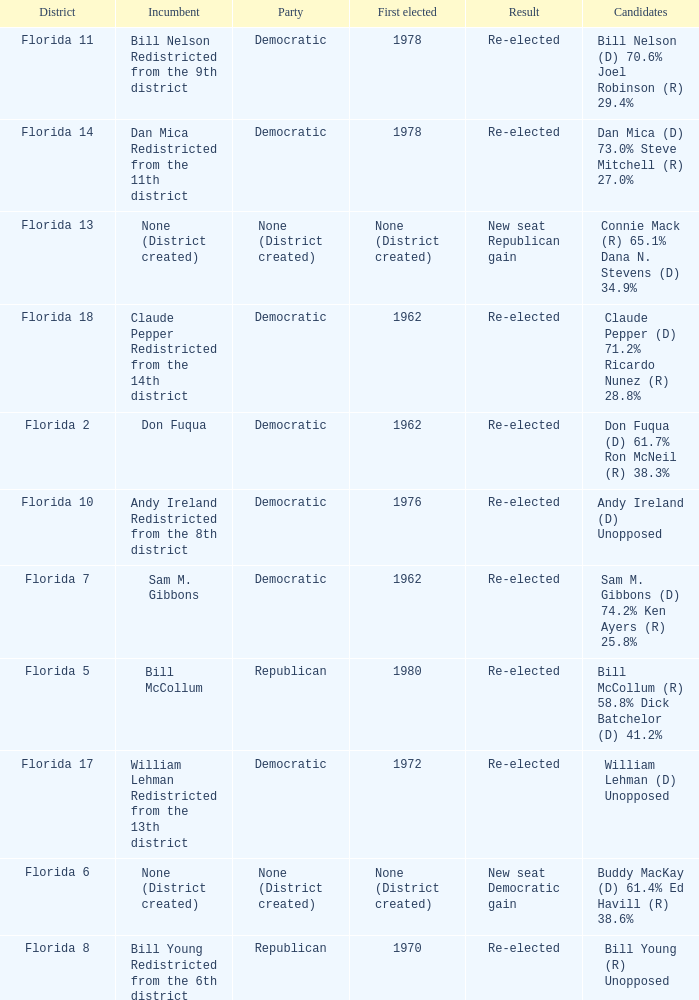 how many result with district being florida 14 1.0. 